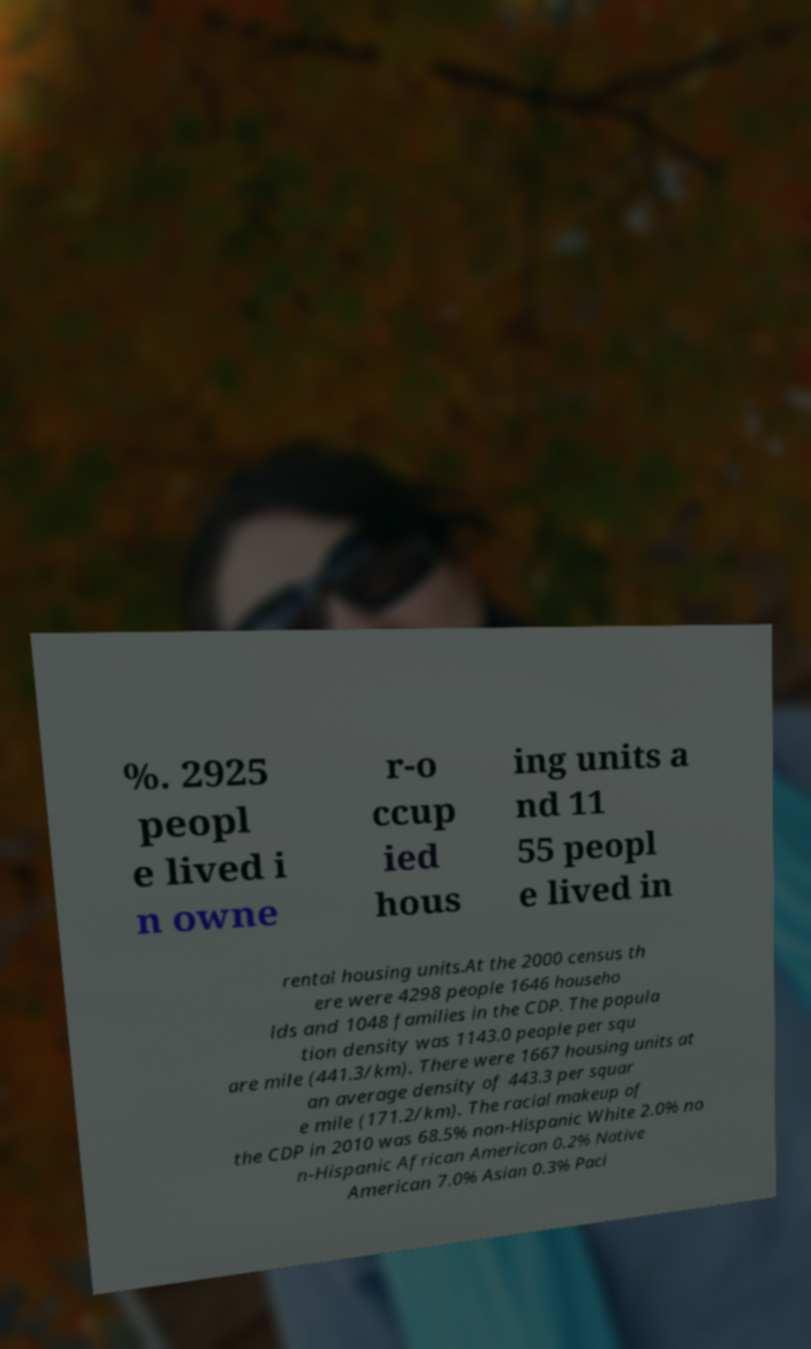What messages or text are displayed in this image? I need them in a readable, typed format. %. 2925 peopl e lived i n owne r-o ccup ied hous ing units a nd 11 55 peopl e lived in rental housing units.At the 2000 census th ere were 4298 people 1646 househo lds and 1048 families in the CDP. The popula tion density was 1143.0 people per squ are mile (441.3/km). There were 1667 housing units at an average density of 443.3 per squar e mile (171.2/km). The racial makeup of the CDP in 2010 was 68.5% non-Hispanic White 2.0% no n-Hispanic African American 0.2% Native American 7.0% Asian 0.3% Paci 